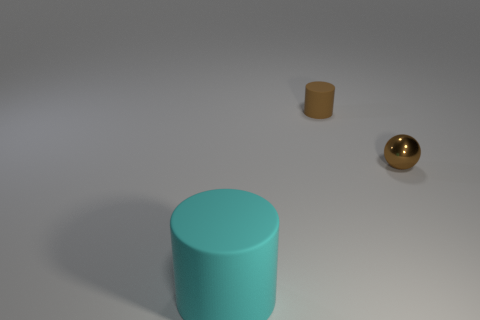Add 2 large gray matte things. How many objects exist? 5 Subtract all balls. How many objects are left? 2 Subtract 1 brown balls. How many objects are left? 2 Subtract all big cyan things. Subtract all brown shiny objects. How many objects are left? 1 Add 2 large cyan things. How many large cyan things are left? 3 Add 1 cyan cylinders. How many cyan cylinders exist? 2 